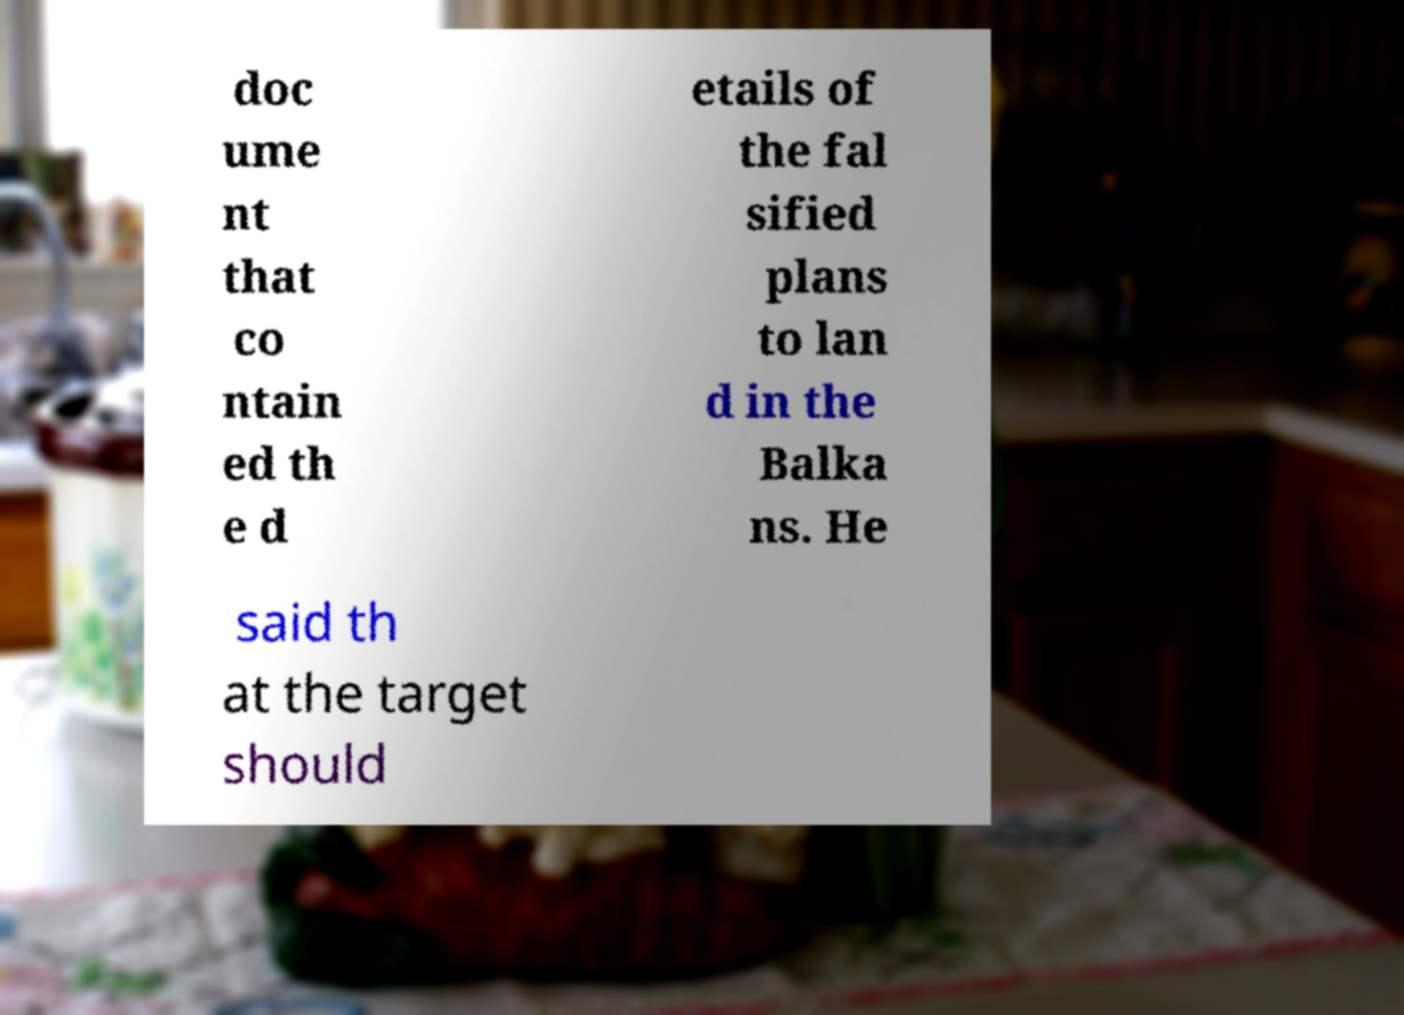There's text embedded in this image that I need extracted. Can you transcribe it verbatim? doc ume nt that co ntain ed th e d etails of the fal sified plans to lan d in the Balka ns. He said th at the target should 